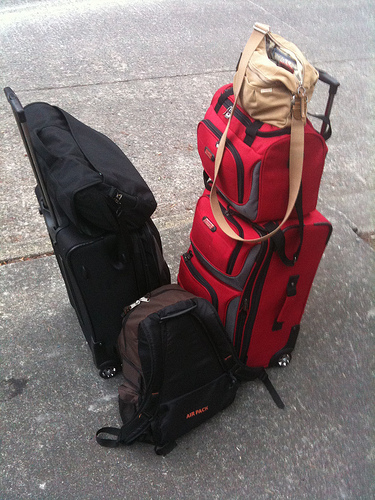Please provide a short description for this region: [0.32, 0.57, 0.7, 0.91]. This region features a sizeable brown and black air pack backpack. Its design suggests versatility and robustness, likely used for adventurous or lengthy travels. 